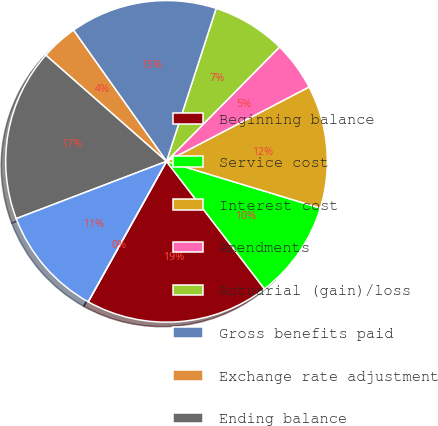Convert chart. <chart><loc_0><loc_0><loc_500><loc_500><pie_chart><fcel>Beginning balance<fcel>Service cost<fcel>Interest cost<fcel>Amendments<fcel>Actuarial (gain)/loss<fcel>Gross benefits paid<fcel>Exchange rate adjustment<fcel>Ending balance<fcel>Beginning balance at fair<fcel>Actual return/(loss) on plan<nl><fcel>18.52%<fcel>9.88%<fcel>12.35%<fcel>4.94%<fcel>7.41%<fcel>14.81%<fcel>3.7%<fcel>17.28%<fcel>11.11%<fcel>0.0%<nl></chart> 